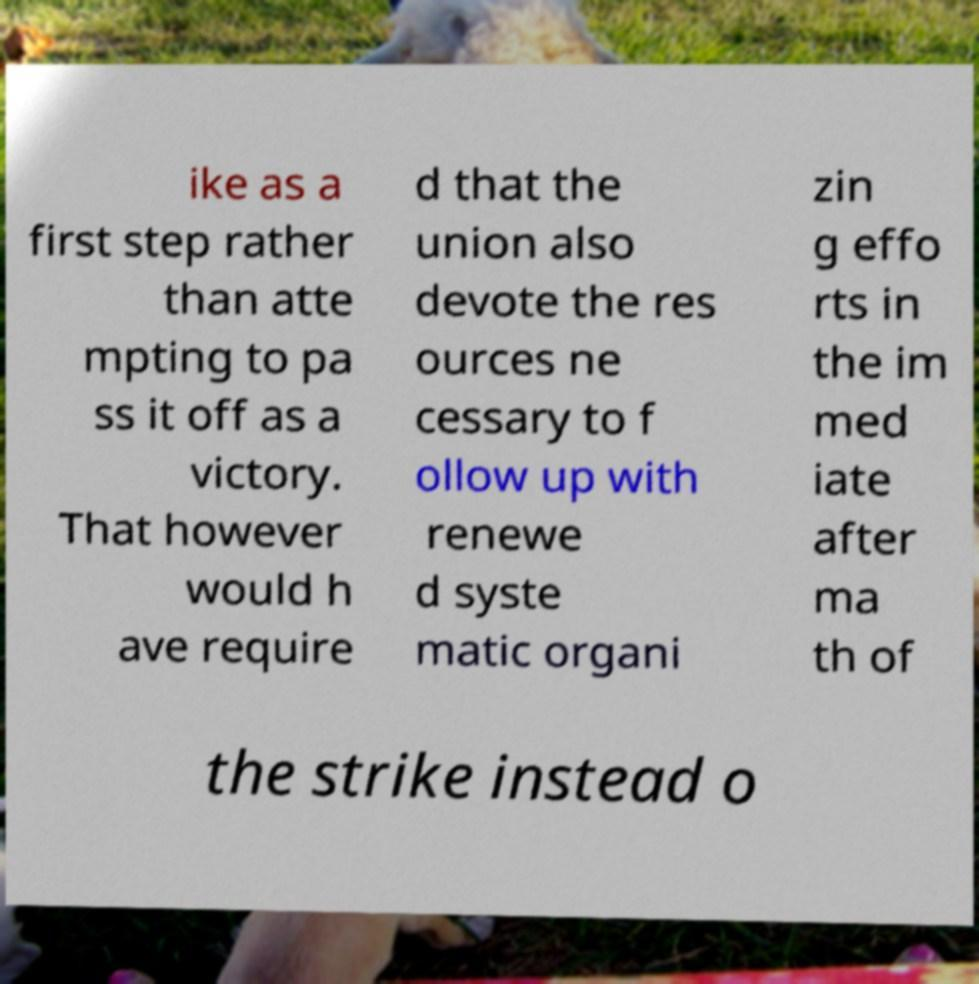I need the written content from this picture converted into text. Can you do that? ike as a first step rather than atte mpting to pa ss it off as a victory. That however would h ave require d that the union also devote the res ources ne cessary to f ollow up with renewe d syste matic organi zin g effo rts in the im med iate after ma th of the strike instead o 